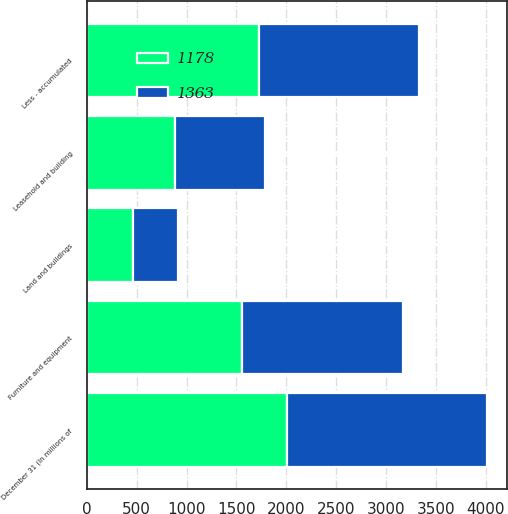Convert chart to OTSL. <chart><loc_0><loc_0><loc_500><loc_500><stacked_bar_chart><ecel><fcel>December 31 (In millions of<fcel>Furniture and equipment<fcel>Land and buildings<fcel>Leasehold and building<fcel>Less - accumulated<nl><fcel>1178<fcel>2005<fcel>1557<fcel>457<fcel>888<fcel>1724<nl><fcel>1363<fcel>2004<fcel>1612<fcel>457<fcel>897<fcel>1603<nl></chart> 